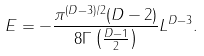<formula> <loc_0><loc_0><loc_500><loc_500>E = - \frac { \pi ^ { ( D - 3 ) / 2 } ( D - 2 ) } { 8 \Gamma \left ( \frac { D - 1 } { 2 } \right ) } L ^ { D - 3 } .</formula> 